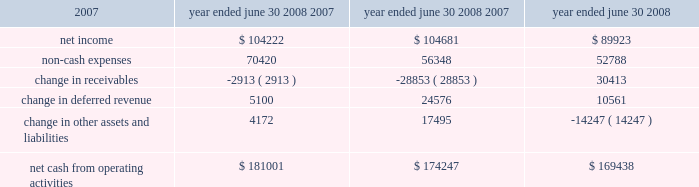L iquidity and capital resources we have historically generated positive cash flow from operations and have generally used funds generated from operations and short-term borrowings on our revolving credit facility to meet capital requirements .
We expect this trend to continue in the future .
The company's cash and cash equivalents decreased to $ 65565 at june 30 , 2008 from $ 88617 at june 30 , 2007 .
The table summarizes net cash from operating activities in the statement of cash flows : year ended june 30 cash provided by operations increased $ 6754 to $ 181001 for the fiscal year ended june 30 , 2008 as compared to $ 174247 for the fiscal year ended june 30 , 2007 .
This increase is primarily attributable to an increase in expenses that do not have a corresponding cash outflow , such as depreciation and amortization , as a percentage of total net income .
Cash used in investing activities for the fiscal year ended june 2008 was $ 102148 and includes payments for acquisitions of $ 48109 , plus $ 1215 in contingent consideration paid on prior years 2019 acquisitions .
During fiscal 2007 , payments for acquisitions totaled $ 34006 , plus $ 5301 paid on earn-outs and other acquisition adjustments .
Capital expenditures for fiscal 2008 were $ 31105 compared to $ 34202 for fiscal 2007 .
Cash used for software development in fiscal 2008 was $ 23736 compared to $ 20743 during the prior year .
Net cash used in financing activities for the current fiscal year was $ 101905 and includes the repurchase of 4200 shares of our common stock for $ 100996 , the payment of dividends of $ 24683 and $ 429 net repayment on our revolving credit facilities .
Cash used in financing activities was partially offset by proceeds of $ 20394 from the exercise of stock options and the sale of common stock and $ 3809 excess tax benefits from stock option exercises .
During fiscal 2007 , net cash used in financing activities included the repurchase of our common stock for $ 98413 and the payment of dividends of $ 21685 .
As in the current year , cash used in fiscal 2007 was partially offset by proceeds from the exercise of stock options and the sale of common stock of $ 29212 , $ 4640 excess tax benefits from stock option exercises and $ 19388 net borrowings on revolving credit facilities .
At june 30 , 2008 , the company had negative working capital of $ 11418 ; however , the largest component of current liabilities was deferred revenue of $ 212375 .
The cash outlay necessary to provide the services related to these deferred revenues is significantly less than this recorded balance .
Therefore , we do not anticipate any liquidity problems to result from this condition .
U.s .
Financial markets and many of the largest u.s .
Financial institutions have recently been shaken by negative developments in the home mortgage industry and the mortgage markets , and particularly the markets for subprime mortgage-backed securities .
While we believe it is too early to predict what effect , if any , these developments may have , we have not experienced any significant issues with our current collec- tion efforts , and we believe that any future impact to our liquidity would be minimized by our access to available lines of credit .
2008 2007 2006 .

In fiscal 2008 , what percentage of net cash for investment activities came from payments for acquisitions? 
Computations: (48109 / 102148)
Answer: 0.47097. 